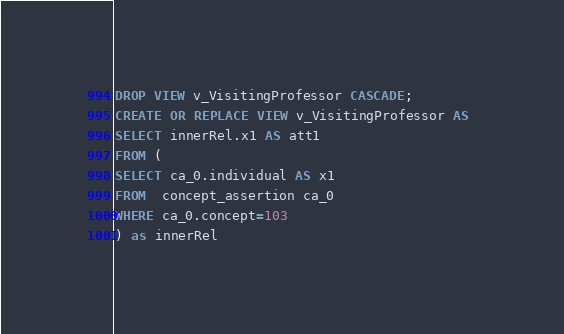Convert code to text. <code><loc_0><loc_0><loc_500><loc_500><_SQL_>DROP VIEW v_VisitingProfessor CASCADE;
CREATE OR REPLACE VIEW v_VisitingProfessor AS 
SELECT innerRel.x1 AS att1
FROM (
SELECT ca_0.individual AS x1
FROM  concept_assertion ca_0
WHERE ca_0.concept=103
) as innerRel
</code> 